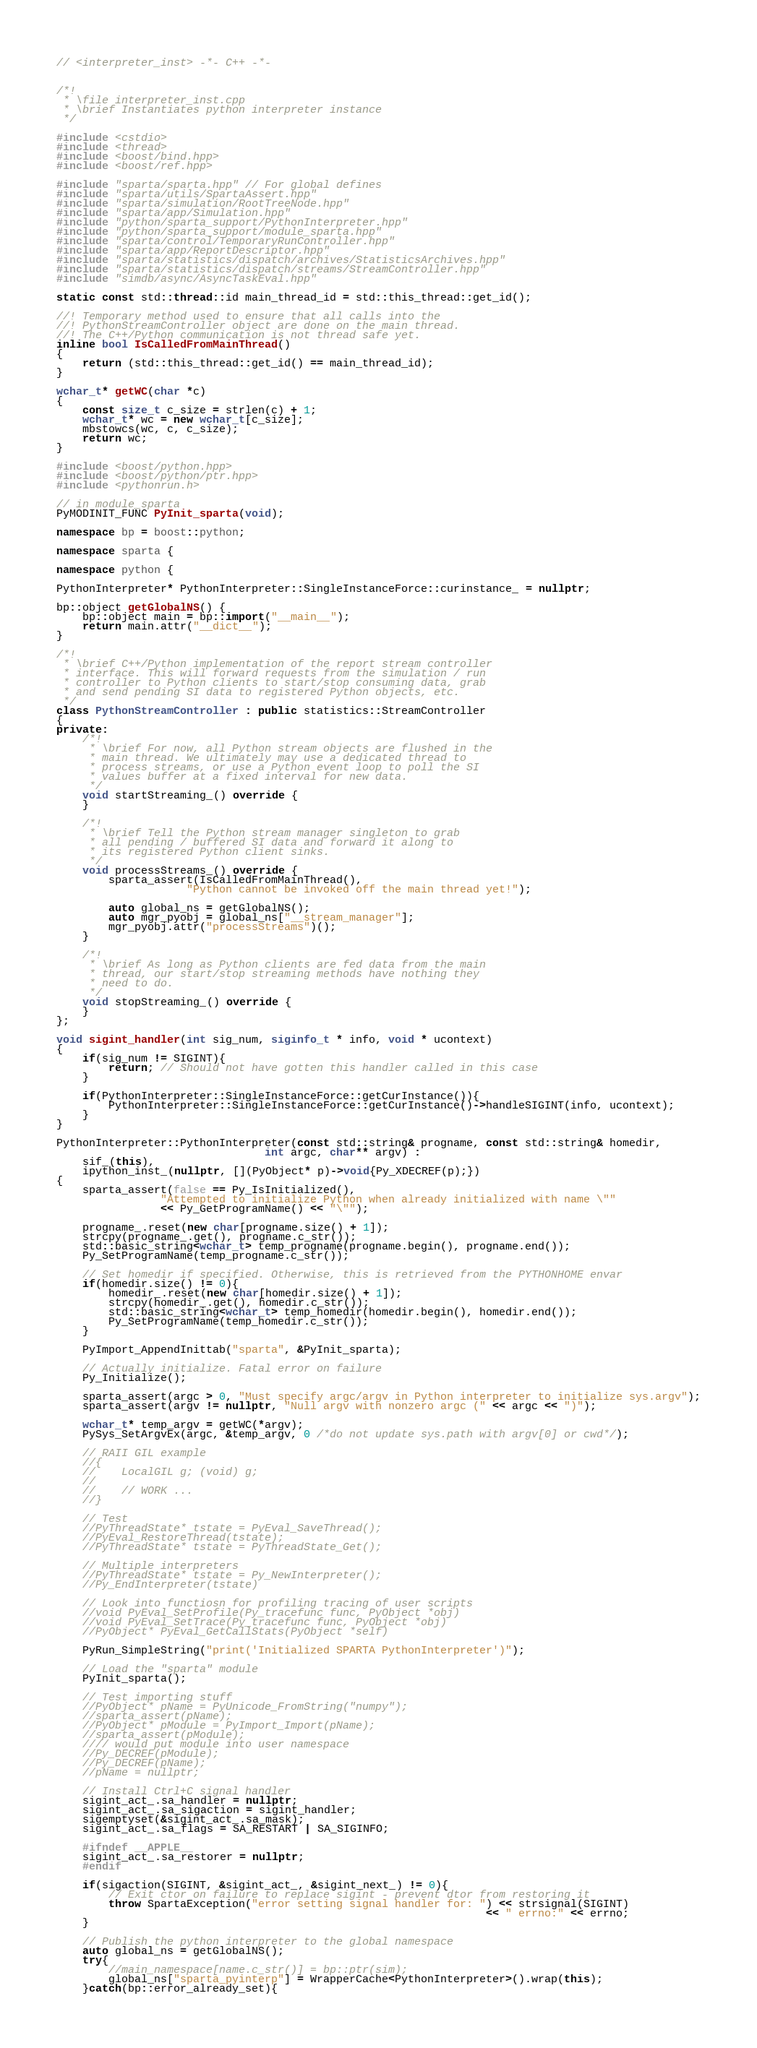<code> <loc_0><loc_0><loc_500><loc_500><_C++_>// <interpreter_inst> -*- C++ -*-


/*!
 * \file interpreter_inst.cpp
 * \brief Instantiates python interpreter instance
 */

#include <cstdio>
#include <thread>
#include <boost/bind.hpp>
#include <boost/ref.hpp>

#include "sparta/sparta.hpp" // For global defines
#include "sparta/utils/SpartaAssert.hpp"
#include "sparta/simulation/RootTreeNode.hpp"
#include "sparta/app/Simulation.hpp"
#include "python/sparta_support/PythonInterpreter.hpp"
#include "python/sparta_support/module_sparta.hpp"
#include "sparta/control/TemporaryRunController.hpp"
#include "sparta/app/ReportDescriptor.hpp"
#include "sparta/statistics/dispatch/archives/StatisticsArchives.hpp"
#include "sparta/statistics/dispatch/streams/StreamController.hpp"
#include "simdb/async/AsyncTaskEval.hpp"

static const std::thread::id main_thread_id = std::this_thread::get_id();

//! Temporary method used to ensure that all calls into the
//! PythonStreamController object are done on the main thread.
//! The C++/Python communication is not thread safe yet.
inline bool IsCalledFromMainThread()
{
    return (std::this_thread::get_id() == main_thread_id);
}

wchar_t* getWC(char *c)
{
    const size_t c_size = strlen(c) + 1;
    wchar_t* wc = new wchar_t[c_size];
    mbstowcs(wc, c, c_size);
    return wc;
}

#include <boost/python.hpp>
#include <boost/python/ptr.hpp>
#include <pythonrun.h>

// in module_sparta
PyMODINIT_FUNC PyInit_sparta(void);

namespace bp = boost::python;

namespace sparta {

namespace python {

PythonInterpreter* PythonInterpreter::SingleInstanceForce::curinstance_ = nullptr;

bp::object getGlobalNS() {
    bp::object main = bp::import("__main__");
    return main.attr("__dict__");
}

/*!
 * \brief C++/Python implementation of the report stream controller
 * interface. This will forward requests from the simulation / run
 * controller to Python clients to start/stop consuming data, grab
 * and send pending SI data to registered Python objects, etc.
 */
class PythonStreamController : public statistics::StreamController
{
private:
    /*!
     * \brief For now, all Python stream objects are flushed in the
     * main thread. We ultimately may use a dedicated thread to
     * process streams, or use a Python event loop to poll the SI
     * values buffer at a fixed interval for new data.
     */
    void startStreaming_() override {
    }

    /*!
     * \brief Tell the Python stream manager singleton to grab
     * all pending / buffered SI data and forward it along to
     * its registered Python client sinks.
     */
    void processStreams_() override {
        sparta_assert(IsCalledFromMainThread(),
                    "Python cannot be invoked off the main thread yet!");

        auto global_ns = getGlobalNS();
        auto mgr_pyobj = global_ns["__stream_manager"];
        mgr_pyobj.attr("processStreams")();
    }

    /*!
     * \brief As long as Python clients are fed data from the main
     * thread, our start/stop streaming methods have nothing they
     * need to do.
     */
    void stopStreaming_() override {
    }
};

void sigint_handler(int sig_num, siginfo_t * info, void * ucontext)
{
    if(sig_num != SIGINT){
        return; // Should not have gotten this handler called in this case
    }

    if(PythonInterpreter::SingleInstanceForce::getCurInstance()){
        PythonInterpreter::SingleInstanceForce::getCurInstance()->handleSIGINT(info, ucontext);
    }
}

PythonInterpreter::PythonInterpreter(const std::string& progname, const std::string& homedir,
                                int argc, char** argv) :
    sif_(this),
    ipython_inst_(nullptr, [](PyObject* p)->void{Py_XDECREF(p);})
{
    sparta_assert(false == Py_IsInitialized(),
                "Attempted to initialize Python when already initialized with name \""
                << Py_GetProgramName() << "\"");

    progname_.reset(new char[progname.size() + 1]);
    strcpy(progname_.get(), progname.c_str());
    std::basic_string<wchar_t> temp_progname(progname.begin(), progname.end());
    Py_SetProgramName(temp_progname.c_str());

    // Set homedir if specified. Otherwise, this is retrieved from the PYTHONHOME envar
    if(homedir.size() != 0){
        homedir_.reset(new char[homedir.size() + 1]);
        strcpy(homedir_.get(), homedir.c_str());
        std::basic_string<wchar_t> temp_homedir(homedir.begin(), homedir.end());
        Py_SetProgramName(temp_homedir.c_str());
    }

    PyImport_AppendInittab("sparta", &PyInit_sparta);

    // Actually initialize. Fatal error on failure
    Py_Initialize();

    sparta_assert(argc > 0, "Must specify argc/argv in Python interpreter to initialize sys.argv");
    sparta_assert(argv != nullptr, "Null argv with nonzero argc (" << argc << ")");

    wchar_t* temp_argv = getWC(*argv);
    PySys_SetArgvEx(argc, &temp_argv, 0 /*do not update sys.path with argv[0] or cwd*/);

    // RAII GIL example
    //{
    //    LocalGIL g; (void) g;
    //
    //    // WORK ...
    //}

    // Test
    //PyThreadState* tstate = PyEval_SaveThread();
    //PyEval_RestoreThread(tstate);
    //PyThreadState* tstate = PyThreadState_Get();

    // Multiple interpreters
    //PyThreadState* tstate = Py_NewInterpreter();
    //Py_EndInterpreter(tstate)

    // Look into functiosn for profiling tracing of user scripts
    //void PyEval_SetProfile(Py_tracefunc func, PyObject *obj)
    //void PyEval_SetTrace(Py_tracefunc func, PyObject *obj)
    //PyObject* PyEval_GetCallStats(PyObject *self)

    PyRun_SimpleString("print('Initialized SPARTA PythonInterpreter')");

    // Load the "sparta" module
    PyInit_sparta();

    // Test importing stuff
    //PyObject* pName = PyUnicode_FromString("numpy");
    //sparta_assert(pName);
    //PyObject* pModule = PyImport_Import(pName);
    //sparta_assert(pModule);
    //// would put module into user namespace
    //Py_DECREF(pModule);
    //Py_DECREF(pName);
    //pName = nullptr;

    // Install Ctrl+C signal handler
    sigint_act_.sa_handler = nullptr;
    sigint_act_.sa_sigaction = sigint_handler;
    sigemptyset(&sigint_act_.sa_mask);
    sigint_act_.sa_flags = SA_RESTART | SA_SIGINFO;

    #ifndef __APPLE__
    sigint_act_.sa_restorer = nullptr;
    #endif

    if(sigaction(SIGINT, &sigint_act_, &sigint_next_) != 0){
        // Exit ctor on failure to replace sigint - prevent dtor from restoring it
        throw SpartaException("error setting signal handler for: ") << strsignal(SIGINT)
                                                                  << " errno:" << errno;
    }

    // Publish the python interpreter to the global namespace
    auto global_ns = getGlobalNS();
    try{
        //main_namespace[name.c_str()] = bp::ptr(sim);
        global_ns["sparta_pyinterp"] = WrapperCache<PythonInterpreter>().wrap(this);
    }catch(bp::error_already_set){</code> 